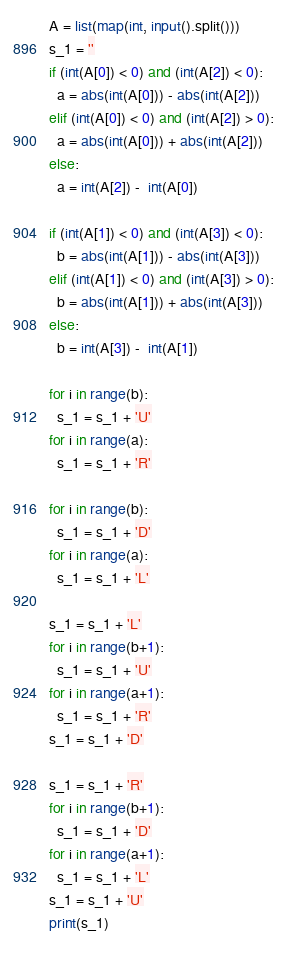<code> <loc_0><loc_0><loc_500><loc_500><_Python_>A = list(map(int, input().split()))
s_1 = ''
if (int(A[0]) < 0) and (int(A[2]) < 0):
  a = abs(int(A[0])) - abs(int(A[2]))
elif (int(A[0]) < 0) and (int(A[2]) > 0):
  a = abs(int(A[0])) + abs(int(A[2]))
else:
  a = int(A[2]) -  int(A[0])
  
if (int(A[1]) < 0) and (int(A[3]) < 0):
  b = abs(int(A[1])) - abs(int(A[3]))
elif (int(A[1]) < 0) and (int(A[3]) > 0):
  b = abs(int(A[1])) + abs(int(A[3]))
else:
  b = int(A[3]) -  int(A[1])

for i in range(b):
  s_1 = s_1 + 'U'
for i in range(a):
  s_1 = s_1 + 'R'
  
for i in range(b):
  s_1 = s_1 + 'D'
for i in range(a):
  s_1 = s_1 + 'L'
  
s_1 = s_1 + 'L'
for i in range(b+1):
  s_1 = s_1 + 'U'
for i in range(a+1):
  s_1 = s_1 + 'R'
s_1 = s_1 + 'D'
  
s_1 = s_1 + 'R'
for i in range(b+1):
  s_1 = s_1 + 'D'
for i in range(a+1):
  s_1 = s_1 + 'L'
s_1 = s_1 + 'U'
print(s_1)
  </code> 